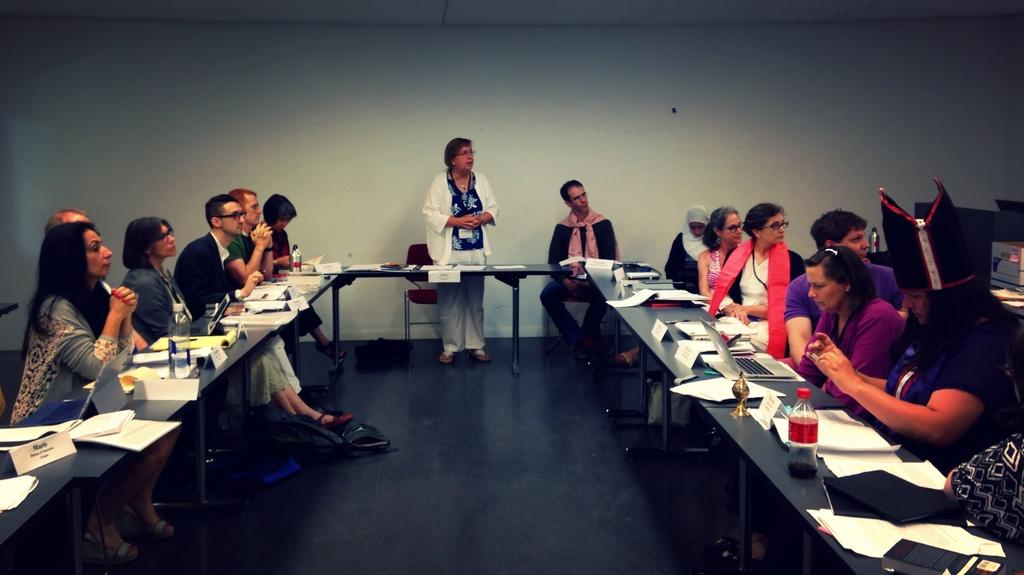How many people are in the image? There is a group of people in the image, but the exact number cannot be determined from the provided facts. What are the people doing in the image? The people are sitting in front of a table in the image. What objects can be seen on the table? There is a laptop, papers, and a bottle on the table in the image. What type of mark can be seen on the texture of the butter in the image? There is no butter present in the image, so it is not possible to answer that question. 